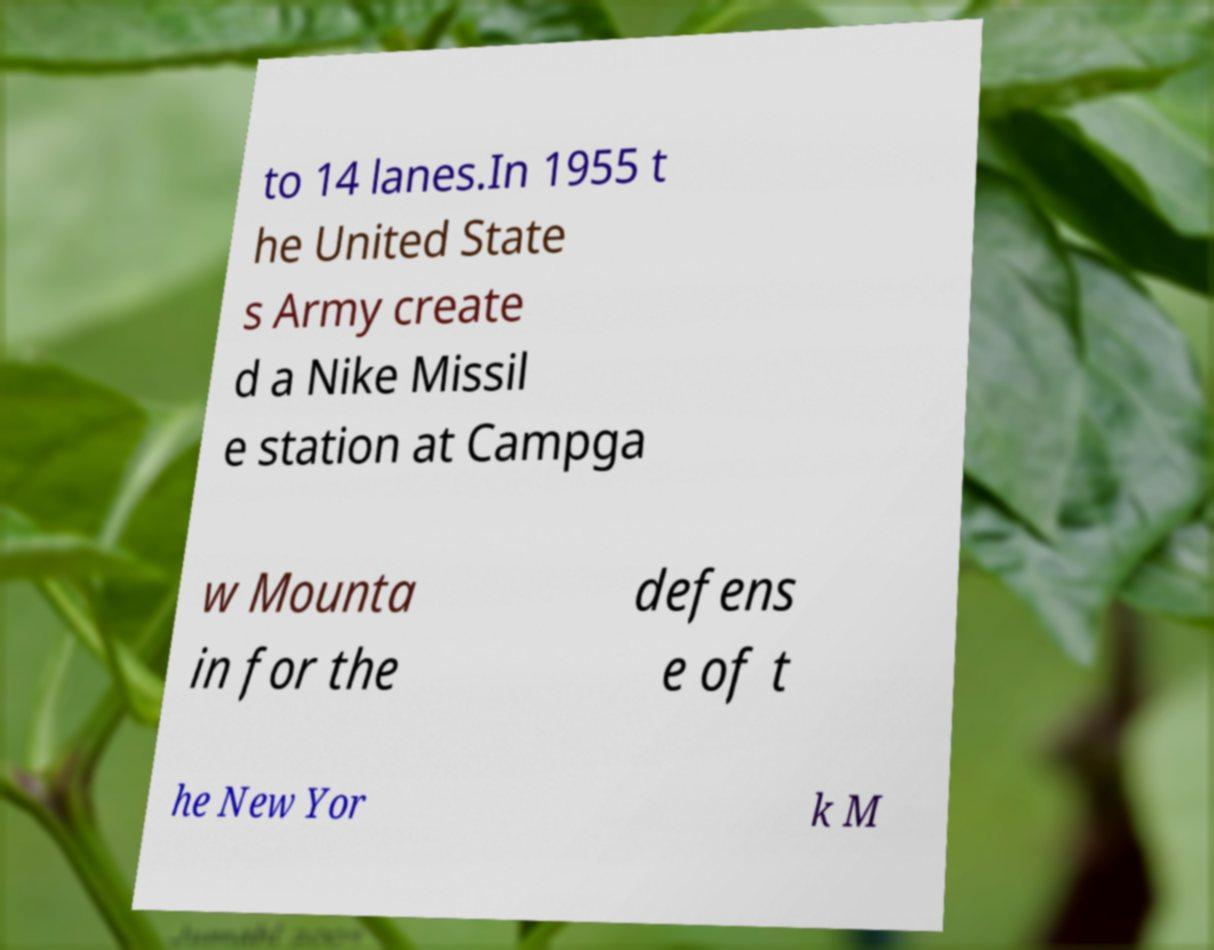What messages or text are displayed in this image? I need them in a readable, typed format. to 14 lanes.In 1955 t he United State s Army create d a Nike Missil e station at Campga w Mounta in for the defens e of t he New Yor k M 